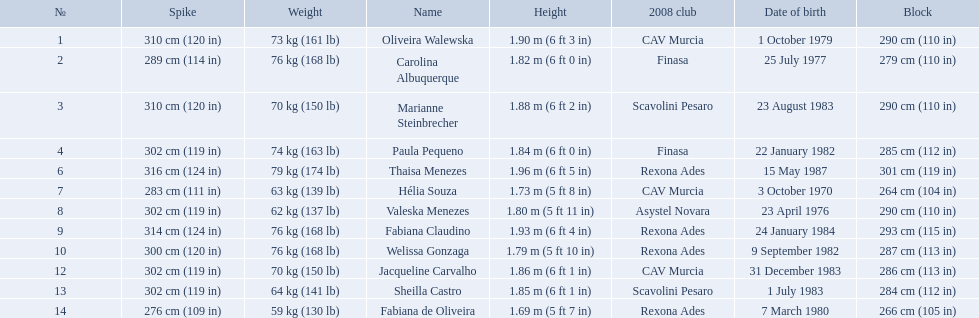What are all of the names? Oliveira Walewska, Carolina Albuquerque, Marianne Steinbrecher, Paula Pequeno, Thaisa Menezes, Hélia Souza, Valeska Menezes, Fabiana Claudino, Welissa Gonzaga, Jacqueline Carvalho, Sheilla Castro, Fabiana de Oliveira. What are their weights? 73 kg (161 lb), 76 kg (168 lb), 70 kg (150 lb), 74 kg (163 lb), 79 kg (174 lb), 63 kg (139 lb), 62 kg (137 lb), 76 kg (168 lb), 76 kg (168 lb), 70 kg (150 lb), 64 kg (141 lb), 59 kg (130 lb). How much did helia souza, fabiana de oliveira, and sheilla castro weigh? Hélia Souza, Sheilla Castro, Fabiana de Oliveira. And who weighed more? Sheilla Castro. Who are the players for brazil at the 2008 summer olympics? Oliveira Walewska, Carolina Albuquerque, Marianne Steinbrecher, Paula Pequeno, Thaisa Menezes, Hélia Souza, Valeska Menezes, Fabiana Claudino, Welissa Gonzaga, Jacqueline Carvalho, Sheilla Castro, Fabiana de Oliveira. What are their heights? 1.90 m (6 ft 3 in), 1.82 m (6 ft 0 in), 1.88 m (6 ft 2 in), 1.84 m (6 ft 0 in), 1.96 m (6 ft 5 in), 1.73 m (5 ft 8 in), 1.80 m (5 ft 11 in), 1.93 m (6 ft 4 in), 1.79 m (5 ft 10 in), 1.86 m (6 ft 1 in), 1.85 m (6 ft 1 in), 1.69 m (5 ft 7 in). What is the shortest height? 1.69 m (5 ft 7 in). Which player is that? Fabiana de Oliveira. 